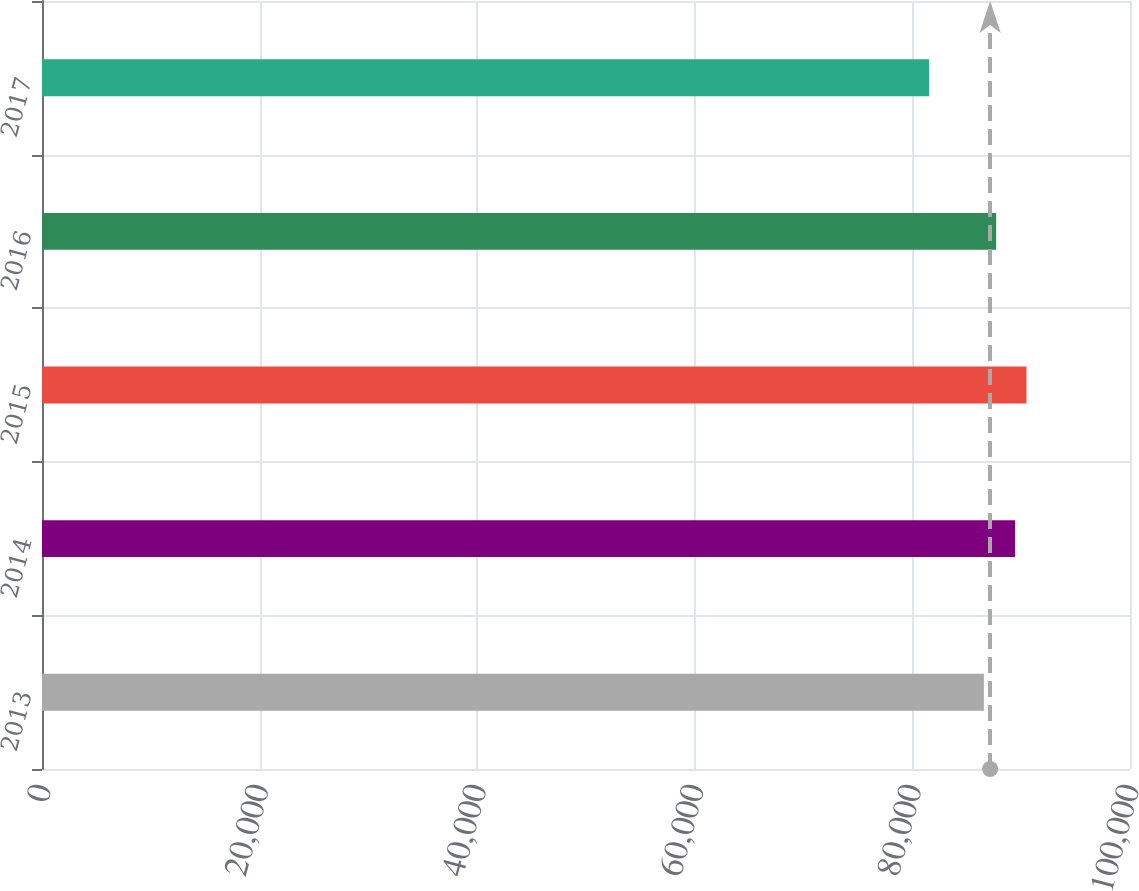Convert chart to OTSL. <chart><loc_0><loc_0><loc_500><loc_500><bar_chart><fcel>2013<fcel>2014<fcel>2015<fcel>2016<fcel>2017<nl><fcel>86570<fcel>89438<fcel>90486<fcel>87698<fcel>81529<nl></chart> 